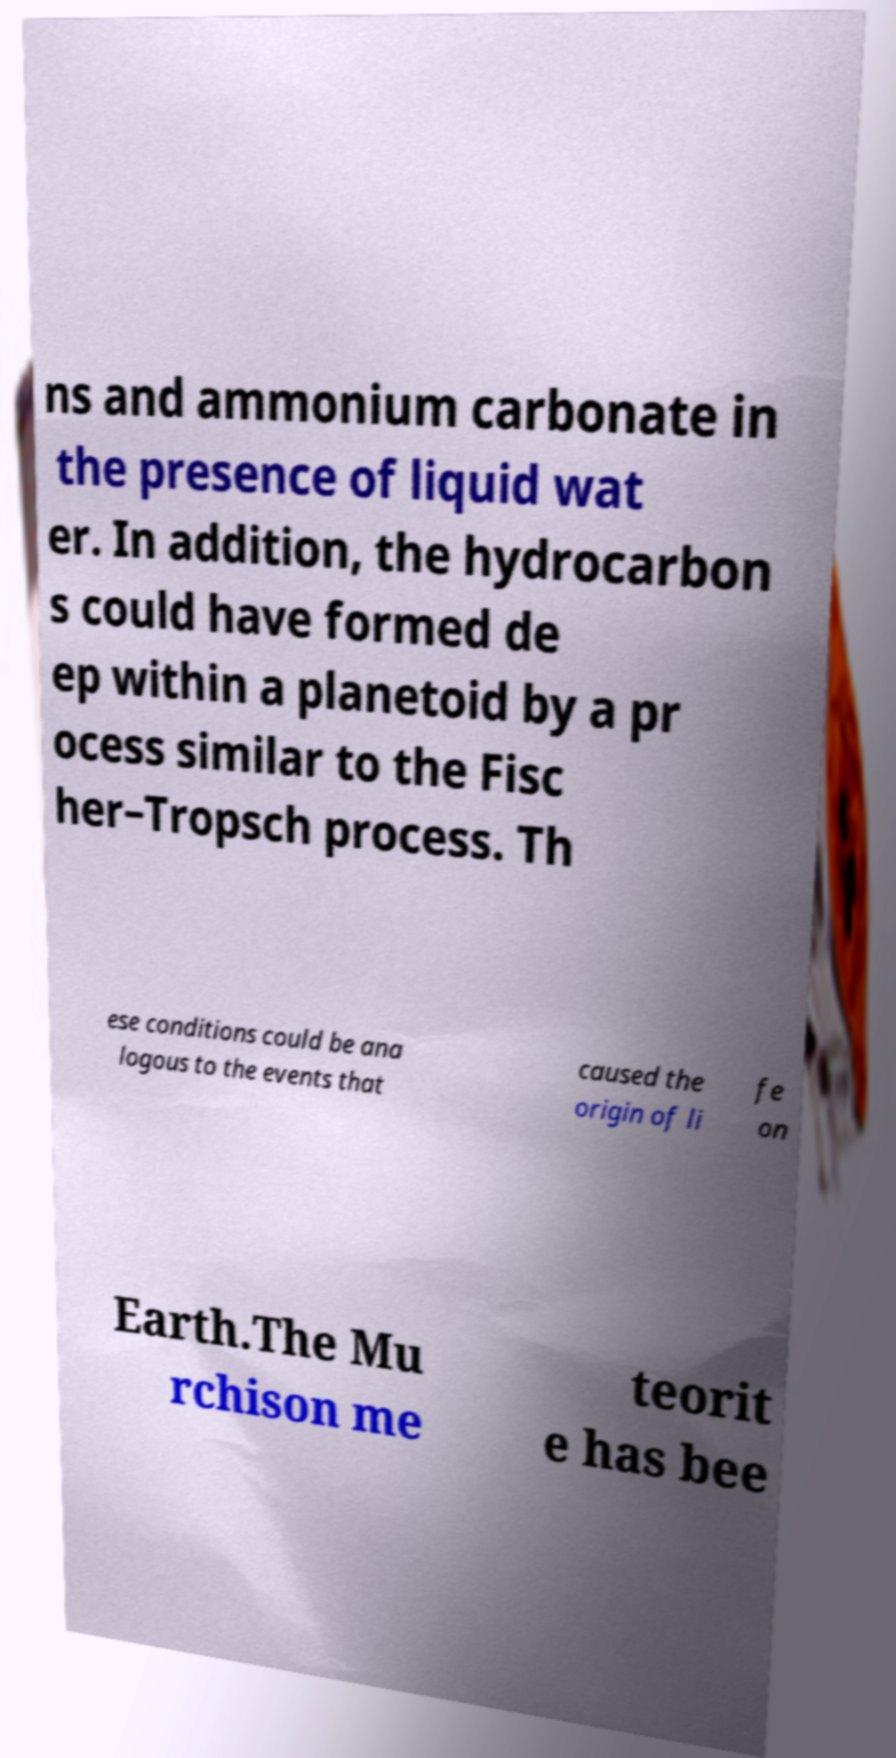For documentation purposes, I need the text within this image transcribed. Could you provide that? ns and ammonium carbonate in the presence of liquid wat er. In addition, the hydrocarbon s could have formed de ep within a planetoid by a pr ocess similar to the Fisc her–Tropsch process. Th ese conditions could be ana logous to the events that caused the origin of li fe on Earth.The Mu rchison me teorit e has bee 